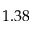<formula> <loc_0><loc_0><loc_500><loc_500>1 . 3 8</formula> 